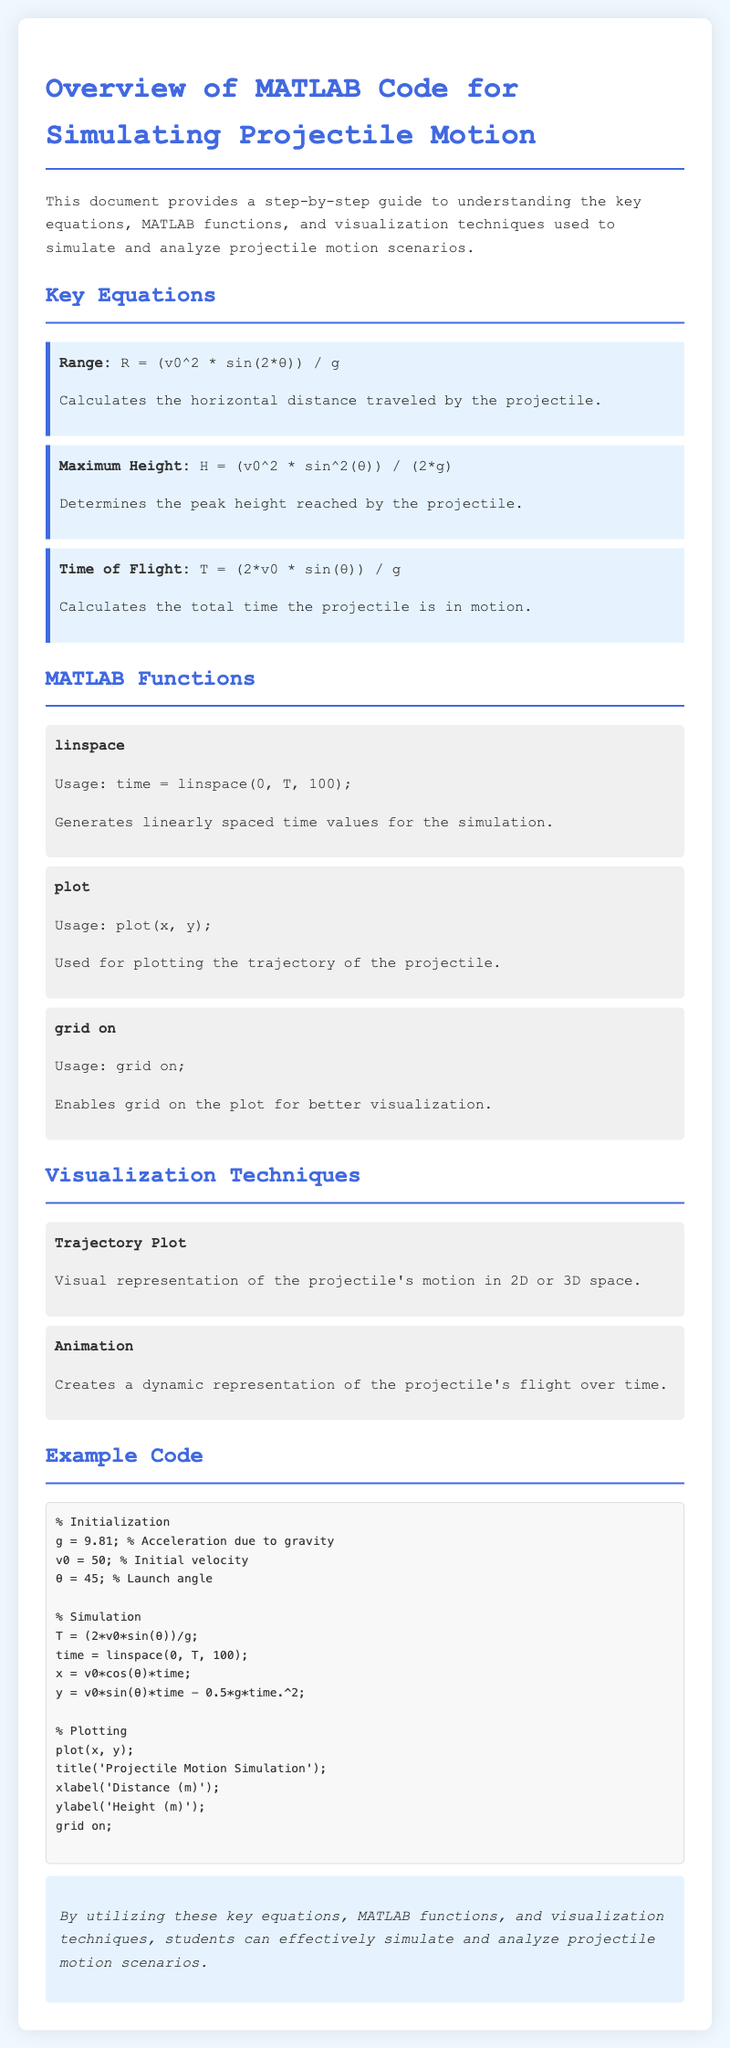What is the acceleration due to gravity used in the simulation? The document specifies the acceleration due to gravity as 9.81.
Answer: 9.81 What function generates linearly spaced time values? The manual describes the function that generates linearly spaced time values as 'linspace'.
Answer: linspace What is the maximum height equation provided? The maximum height equation is stated as H = (v0^2 * sin^2(θ)) / (2*g).
Answer: H = (v0^2 * sin^2(θ)) / (2*g) How many time values are generated for the simulation? The document indicates that 100 time values are generated for the simulation.
Answer: 100 What is the launch angle in the example code? The launch angle in the example code is set to 45 degrees.
Answer: 45 What visualization technique is mentioned for showing dynamic movement? The technique mentioned for dynamic representation of the projectile's flight is called 'Animation'.
Answer: Animation What is the purpose of the 'grid on' function in the context of the document? The document states that the 'grid on' function enables the grid on the plot for better visualization.
Answer: Enables grid What is the equation to calculate the time of flight? The time of flight equation provided is T = (2*v0 * sin(θ)) / g.
Answer: T = (2*v0 * sin(θ)) / g What type of plot is created in the example code? The type of plot created in the example code is a 'Trajectory Plot'.
Answer: Trajectory Plot 